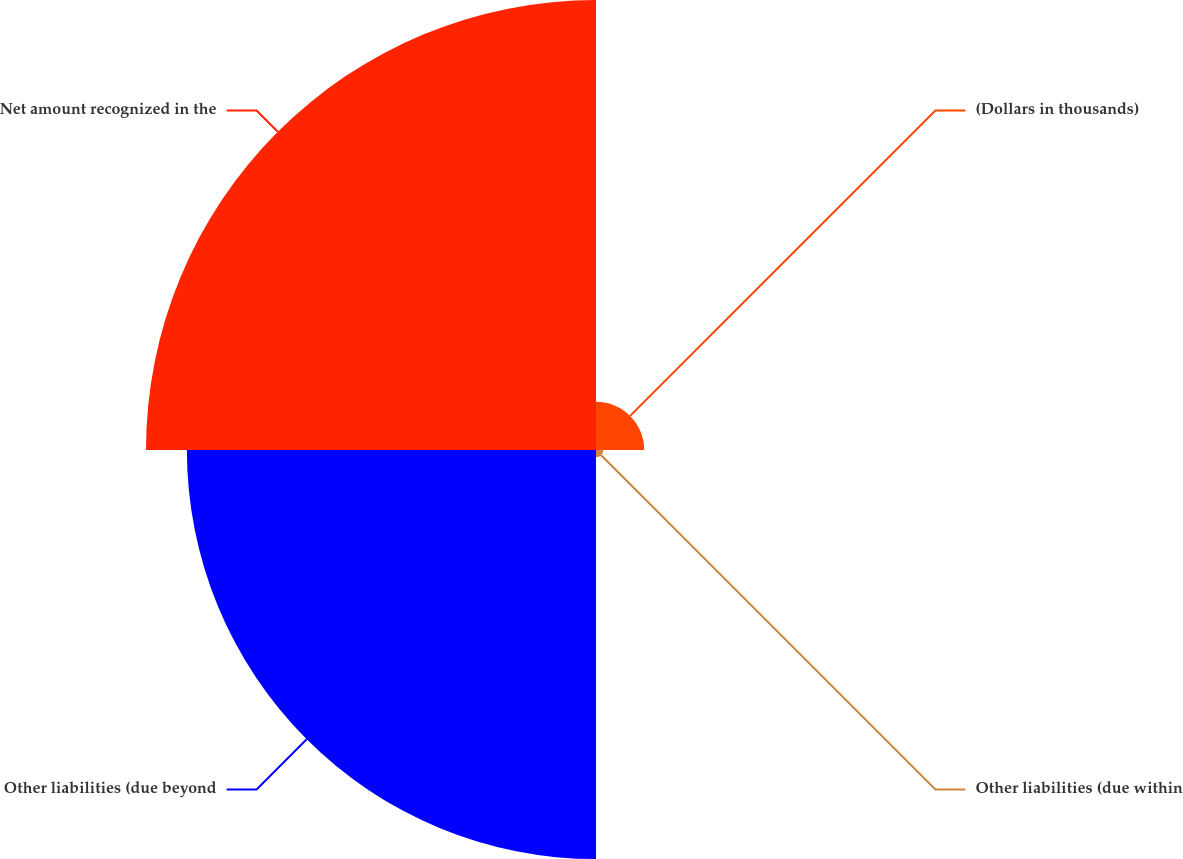Convert chart. <chart><loc_0><loc_0><loc_500><loc_500><pie_chart><fcel>(Dollars in thousands)<fcel>Other liabilities (due within<fcel>Other liabilities (due beyond<fcel>Net amount recognized in the<nl><fcel>5.27%<fcel>0.8%<fcel>44.73%<fcel>49.2%<nl></chart> 